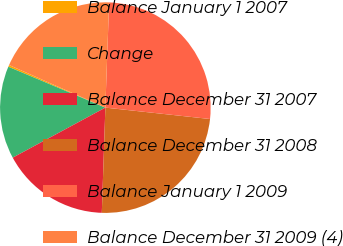Convert chart. <chart><loc_0><loc_0><loc_500><loc_500><pie_chart><fcel>Balance January 1 2007<fcel>Change<fcel>Balance December 31 2007<fcel>Balance December 31 2008<fcel>Balance January 1 2009<fcel>Balance December 31 2009 (4)<nl><fcel>0.28%<fcel>14.23%<fcel>16.58%<fcel>23.81%<fcel>26.16%<fcel>18.94%<nl></chart> 